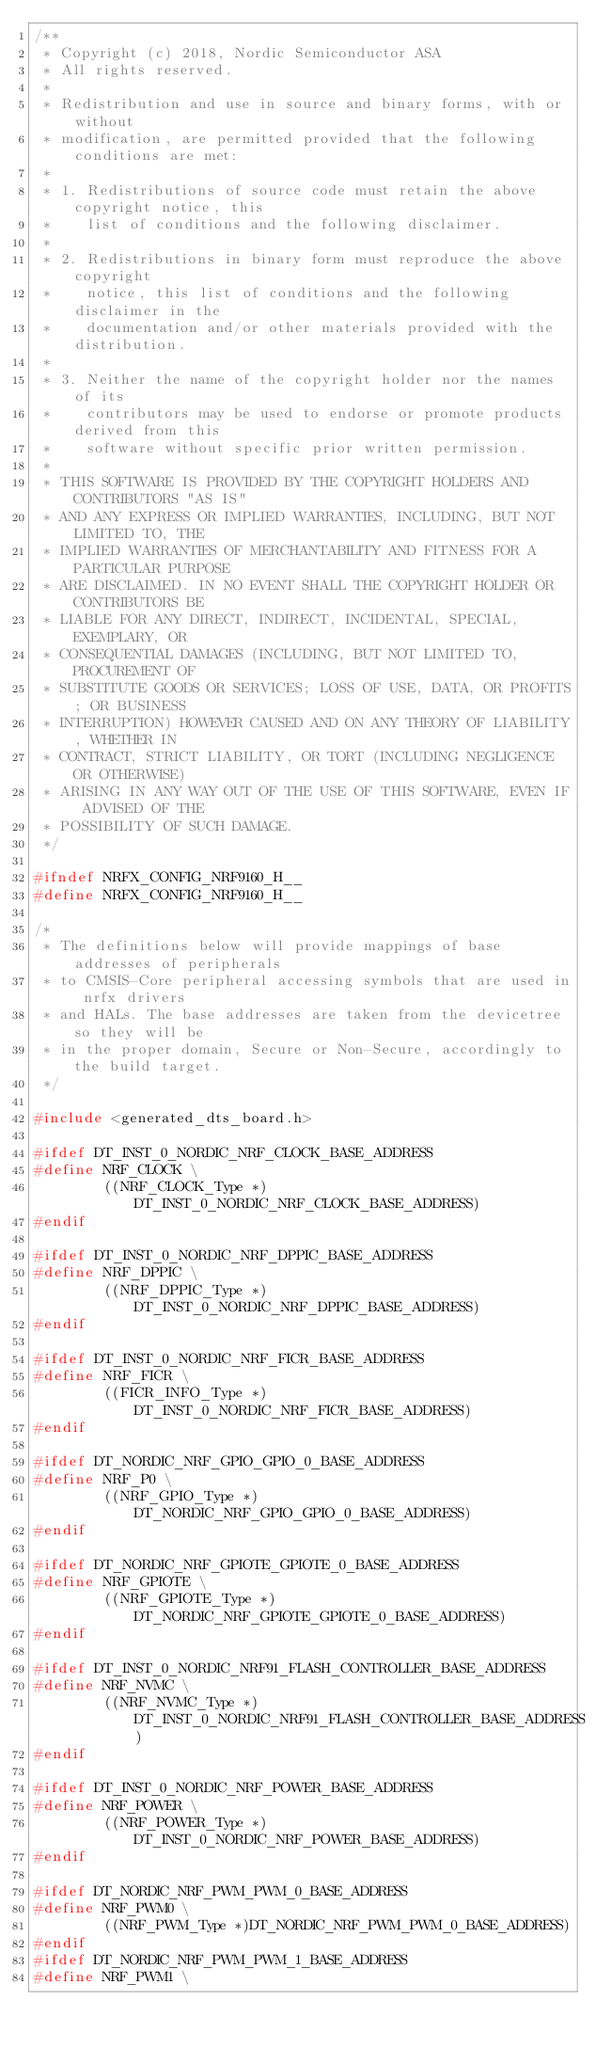<code> <loc_0><loc_0><loc_500><loc_500><_C_>/**
 * Copyright (c) 2018, Nordic Semiconductor ASA
 * All rights reserved.
 *
 * Redistribution and use in source and binary forms, with or without
 * modification, are permitted provided that the following conditions are met:
 *
 * 1. Redistributions of source code must retain the above copyright notice, this
 *    list of conditions and the following disclaimer.
 *
 * 2. Redistributions in binary form must reproduce the above copyright
 *    notice, this list of conditions and the following disclaimer in the
 *    documentation and/or other materials provided with the distribution.
 *
 * 3. Neither the name of the copyright holder nor the names of its
 *    contributors may be used to endorse or promote products derived from this
 *    software without specific prior written permission.
 *
 * THIS SOFTWARE IS PROVIDED BY THE COPYRIGHT HOLDERS AND CONTRIBUTORS "AS IS"
 * AND ANY EXPRESS OR IMPLIED WARRANTIES, INCLUDING, BUT NOT LIMITED TO, THE
 * IMPLIED WARRANTIES OF MERCHANTABILITY AND FITNESS FOR A PARTICULAR PURPOSE
 * ARE DISCLAIMED. IN NO EVENT SHALL THE COPYRIGHT HOLDER OR CONTRIBUTORS BE
 * LIABLE FOR ANY DIRECT, INDIRECT, INCIDENTAL, SPECIAL, EXEMPLARY, OR
 * CONSEQUENTIAL DAMAGES (INCLUDING, BUT NOT LIMITED TO, PROCUREMENT OF
 * SUBSTITUTE GOODS OR SERVICES; LOSS OF USE, DATA, OR PROFITS; OR BUSINESS
 * INTERRUPTION) HOWEVER CAUSED AND ON ANY THEORY OF LIABILITY, WHETHER IN
 * CONTRACT, STRICT LIABILITY, OR TORT (INCLUDING NEGLIGENCE OR OTHERWISE)
 * ARISING IN ANY WAY OUT OF THE USE OF THIS SOFTWARE, EVEN IF ADVISED OF THE
 * POSSIBILITY OF SUCH DAMAGE.
 */

#ifndef NRFX_CONFIG_NRF9160_H__
#define NRFX_CONFIG_NRF9160_H__

/*
 * The definitions below will provide mappings of base addresses of peripherals
 * to CMSIS-Core peripheral accessing symbols that are used in nrfx drivers
 * and HALs. The base addresses are taken from the devicetree so they will be
 * in the proper domain, Secure or Non-Secure, accordingly to the build target.
 */

#include <generated_dts_board.h>

#ifdef DT_INST_0_NORDIC_NRF_CLOCK_BASE_ADDRESS
#define NRF_CLOCK \
        ((NRF_CLOCK_Type *)DT_INST_0_NORDIC_NRF_CLOCK_BASE_ADDRESS)
#endif

#ifdef DT_INST_0_NORDIC_NRF_DPPIC_BASE_ADDRESS
#define NRF_DPPIC \
        ((NRF_DPPIC_Type *)DT_INST_0_NORDIC_NRF_DPPIC_BASE_ADDRESS)
#endif

#ifdef DT_INST_0_NORDIC_NRF_FICR_BASE_ADDRESS
#define NRF_FICR \
        ((FICR_INFO_Type *)DT_INST_0_NORDIC_NRF_FICR_BASE_ADDRESS)
#endif

#ifdef DT_NORDIC_NRF_GPIO_GPIO_0_BASE_ADDRESS
#define NRF_P0 \
        ((NRF_GPIO_Type *)DT_NORDIC_NRF_GPIO_GPIO_0_BASE_ADDRESS)
#endif

#ifdef DT_NORDIC_NRF_GPIOTE_GPIOTE_0_BASE_ADDRESS
#define NRF_GPIOTE \
        ((NRF_GPIOTE_Type *)DT_NORDIC_NRF_GPIOTE_GPIOTE_0_BASE_ADDRESS)
#endif

#ifdef DT_INST_0_NORDIC_NRF91_FLASH_CONTROLLER_BASE_ADDRESS
#define NRF_NVMC \
        ((NRF_NVMC_Type *)DT_INST_0_NORDIC_NRF91_FLASH_CONTROLLER_BASE_ADDRESS)
#endif

#ifdef DT_INST_0_NORDIC_NRF_POWER_BASE_ADDRESS
#define NRF_POWER \
        ((NRF_POWER_Type *)DT_INST_0_NORDIC_NRF_POWER_BASE_ADDRESS)
#endif

#ifdef DT_NORDIC_NRF_PWM_PWM_0_BASE_ADDRESS
#define NRF_PWM0 \
        ((NRF_PWM_Type *)DT_NORDIC_NRF_PWM_PWM_0_BASE_ADDRESS)
#endif
#ifdef DT_NORDIC_NRF_PWM_PWM_1_BASE_ADDRESS
#define NRF_PWM1 \</code> 